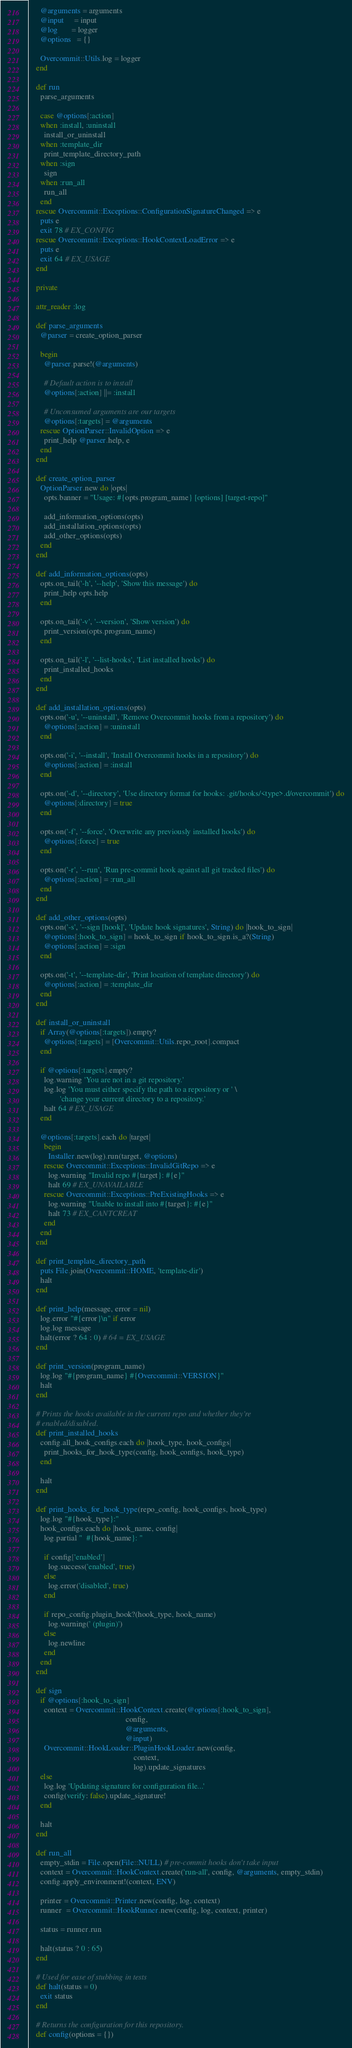Convert code to text. <code><loc_0><loc_0><loc_500><loc_500><_Ruby_>      @arguments = arguments
      @input     = input
      @log       = logger
      @options   = {}

      Overcommit::Utils.log = logger
    end

    def run
      parse_arguments

      case @options[:action]
      when :install, :uninstall
        install_or_uninstall
      when :template_dir
        print_template_directory_path
      when :sign
        sign
      when :run_all
        run_all
      end
    rescue Overcommit::Exceptions::ConfigurationSignatureChanged => e
      puts e
      exit 78 # EX_CONFIG
    rescue Overcommit::Exceptions::HookContextLoadError => e
      puts e
      exit 64 # EX_USAGE
    end

    private

    attr_reader :log

    def parse_arguments
      @parser = create_option_parser

      begin
        @parser.parse!(@arguments)

        # Default action is to install
        @options[:action] ||= :install

        # Unconsumed arguments are our targets
        @options[:targets] = @arguments
      rescue OptionParser::InvalidOption => e
        print_help @parser.help, e
      end
    end

    def create_option_parser
      OptionParser.new do |opts|
        opts.banner = "Usage: #{opts.program_name} [options] [target-repo]"

        add_information_options(opts)
        add_installation_options(opts)
        add_other_options(opts)
      end
    end

    def add_information_options(opts)
      opts.on_tail('-h', '--help', 'Show this message') do
        print_help opts.help
      end

      opts.on_tail('-v', '--version', 'Show version') do
        print_version(opts.program_name)
      end

      opts.on_tail('-l', '--list-hooks', 'List installed hooks') do
        print_installed_hooks
      end
    end

    def add_installation_options(opts)
      opts.on('-u', '--uninstall', 'Remove Overcommit hooks from a repository') do
        @options[:action] = :uninstall
      end

      opts.on('-i', '--install', 'Install Overcommit hooks in a repository') do
        @options[:action] = :install
      end

      opts.on('-d', '--directory', 'Use directory format for hooks: .git/hooks/<type>.d/overcommit') do
        @options[:directory] = true
      end

      opts.on('-f', '--force', 'Overwrite any previously installed hooks') do
        @options[:force] = true
      end

      opts.on('-r', '--run', 'Run pre-commit hook against all git tracked files') do
        @options[:action] = :run_all
      end
    end

    def add_other_options(opts)
      opts.on('-s', '--sign [hook]', 'Update hook signatures', String) do |hook_to_sign|
        @options[:hook_to_sign] = hook_to_sign if hook_to_sign.is_a?(String)
        @options[:action] = :sign
      end

      opts.on('-t', '--template-dir', 'Print location of template directory') do
        @options[:action] = :template_dir
      end
    end

    def install_or_uninstall
      if Array(@options[:targets]).empty?
        @options[:targets] = [Overcommit::Utils.repo_root].compact
      end

      if @options[:targets].empty?
        log.warning 'You are not in a git repository.'
        log.log 'You must either specify the path to a repository or ' \
                'change your current directory to a repository.'
        halt 64 # EX_USAGE
      end

      @options[:targets].each do |target|
        begin
          Installer.new(log).run(target, @options)
        rescue Overcommit::Exceptions::InvalidGitRepo => e
          log.warning "Invalid repo #{target}: #{e}"
          halt 69 # EX_UNAVAILABLE
        rescue Overcommit::Exceptions::PreExistingHooks => e
          log.warning "Unable to install into #{target}: #{e}"
          halt 73 # EX_CANTCREAT
        end
      end
    end

    def print_template_directory_path
      puts File.join(Overcommit::HOME, 'template-dir')
      halt
    end

    def print_help(message, error = nil)
      log.error "#{error}\n" if error
      log.log message
      halt(error ? 64 : 0) # 64 = EX_USAGE
    end

    def print_version(program_name)
      log.log "#{program_name} #{Overcommit::VERSION}"
      halt
    end

    # Prints the hooks available in the current repo and whether they're
    # enabled/disabled.
    def print_installed_hooks
      config.all_hook_configs.each do |hook_type, hook_configs|
        print_hooks_for_hook_type(config, hook_configs, hook_type)
      end

      halt
    end

    def print_hooks_for_hook_type(repo_config, hook_configs, hook_type)
      log.log "#{hook_type}:"
      hook_configs.each do |hook_name, config|
        log.partial "  #{hook_name}: "

        if config['enabled']
          log.success('enabled', true)
        else
          log.error('disabled', true)
        end

        if repo_config.plugin_hook?(hook_type, hook_name)
          log.warning(' (plugin)')
        else
          log.newline
        end
      end
    end

    def sign
      if @options[:hook_to_sign]
        context = Overcommit::HookContext.create(@options[:hook_to_sign],
                                                 config,
                                                 @arguments,
                                                 @input)
        Overcommit::HookLoader::PluginHookLoader.new(config,
                                                     context,
                                                     log).update_signatures
      else
        log.log 'Updating signature for configuration file...'
        config(verify: false).update_signature!
      end

      halt
    end

    def run_all
      empty_stdin = File.open(File::NULL) # pre-commit hooks don't take input
      context = Overcommit::HookContext.create('run-all', config, @arguments, empty_stdin)
      config.apply_environment!(context, ENV)

      printer = Overcommit::Printer.new(config, log, context)
      runner  = Overcommit::HookRunner.new(config, log, context, printer)

      status = runner.run

      halt(status ? 0 : 65)
    end

    # Used for ease of stubbing in tests
    def halt(status = 0)
      exit status
    end

    # Returns the configuration for this repository.
    def config(options = {})</code> 